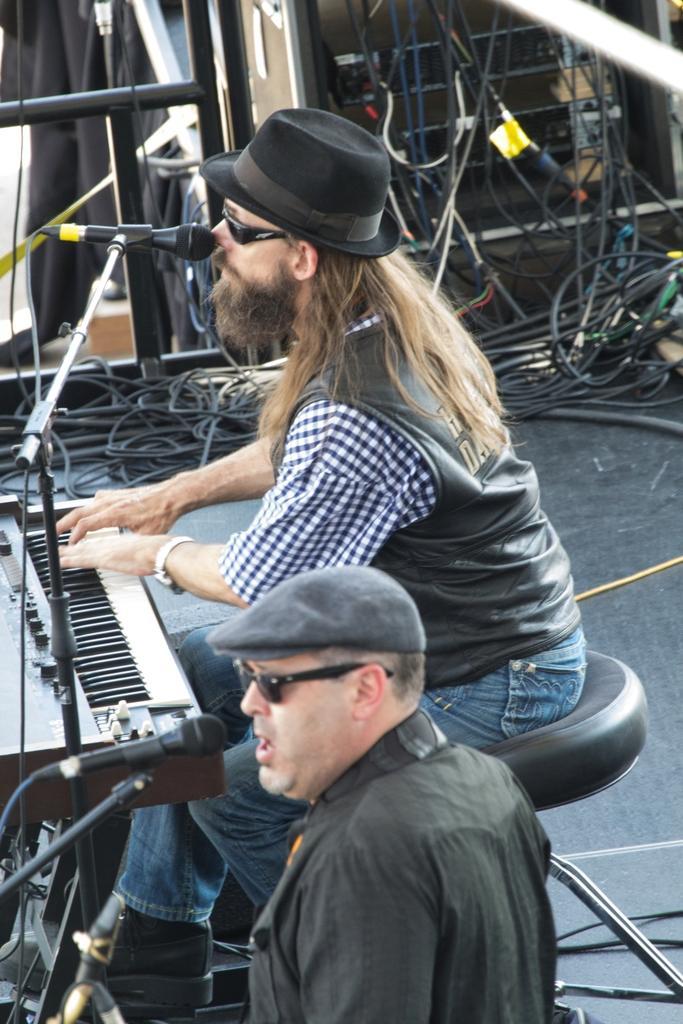How would you summarize this image in a sentence or two? In this picture I can see 2 men who are in front of the mics and I see a piano in front this man. In the background I see an equipment and I see number of wires. 